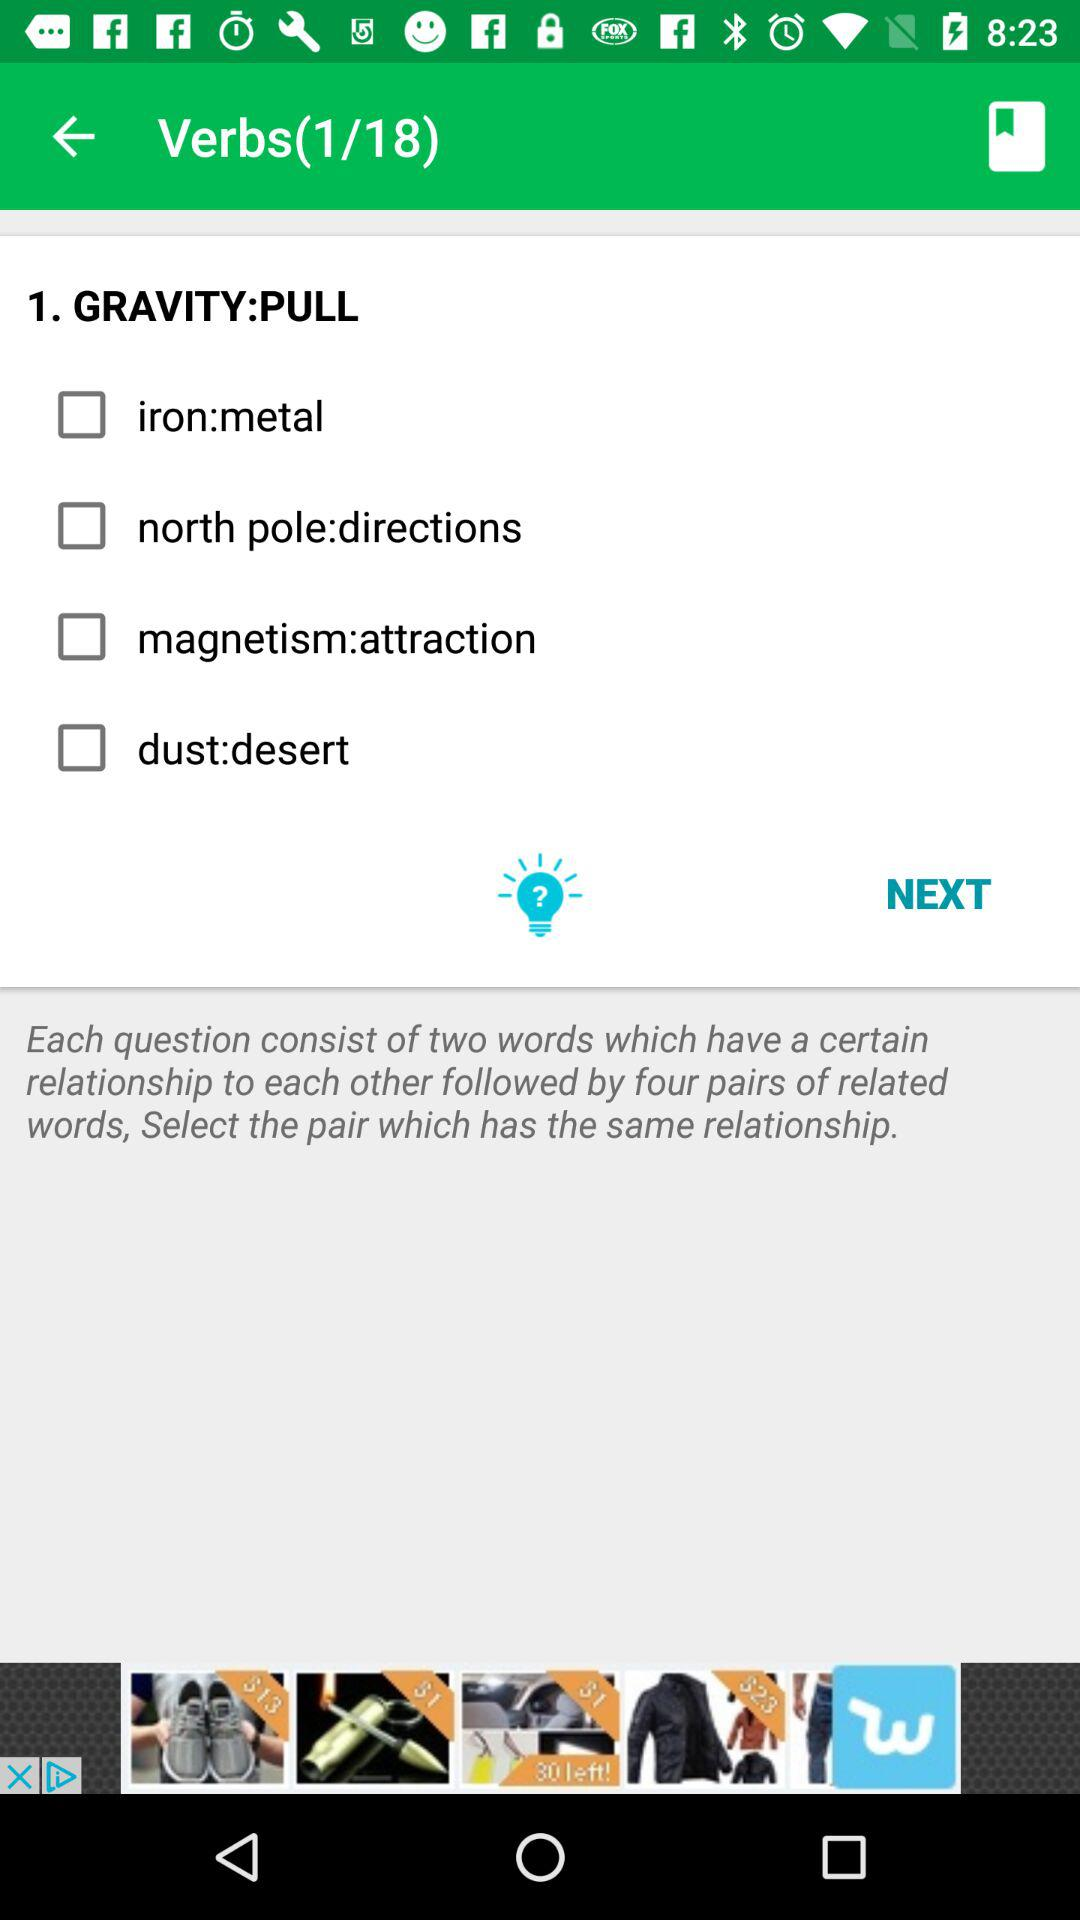At which verb session am I? The verb session in which you are is 1. 